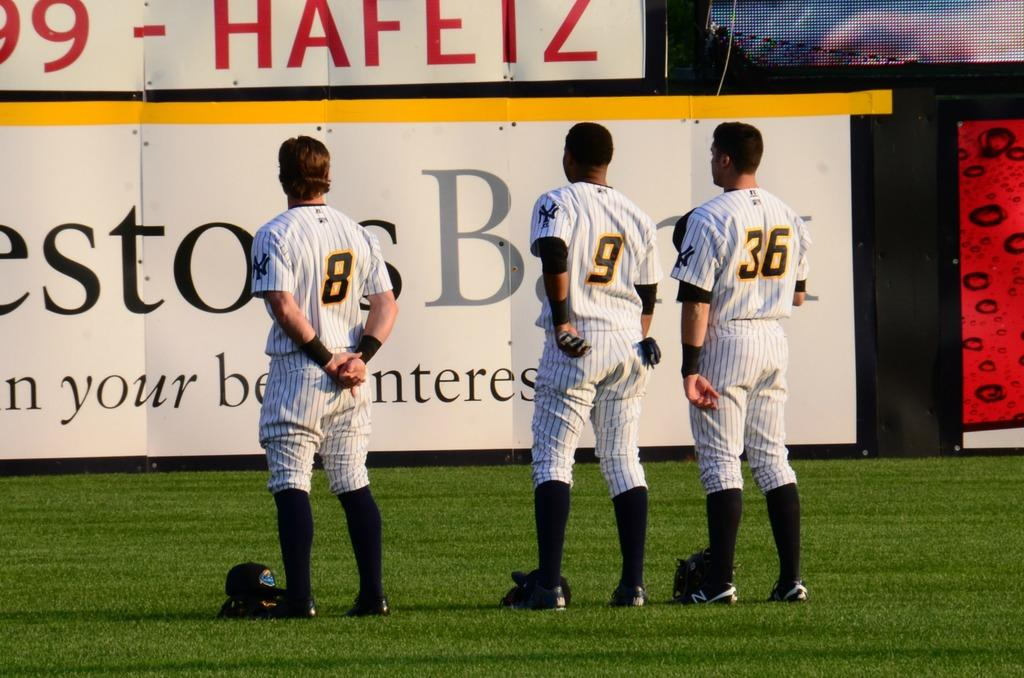Provide a one-sentence caption for the provided image. A group of three baseball players facing an advertisement with the numbers 8,9, and 36 on the back of their shirts. 